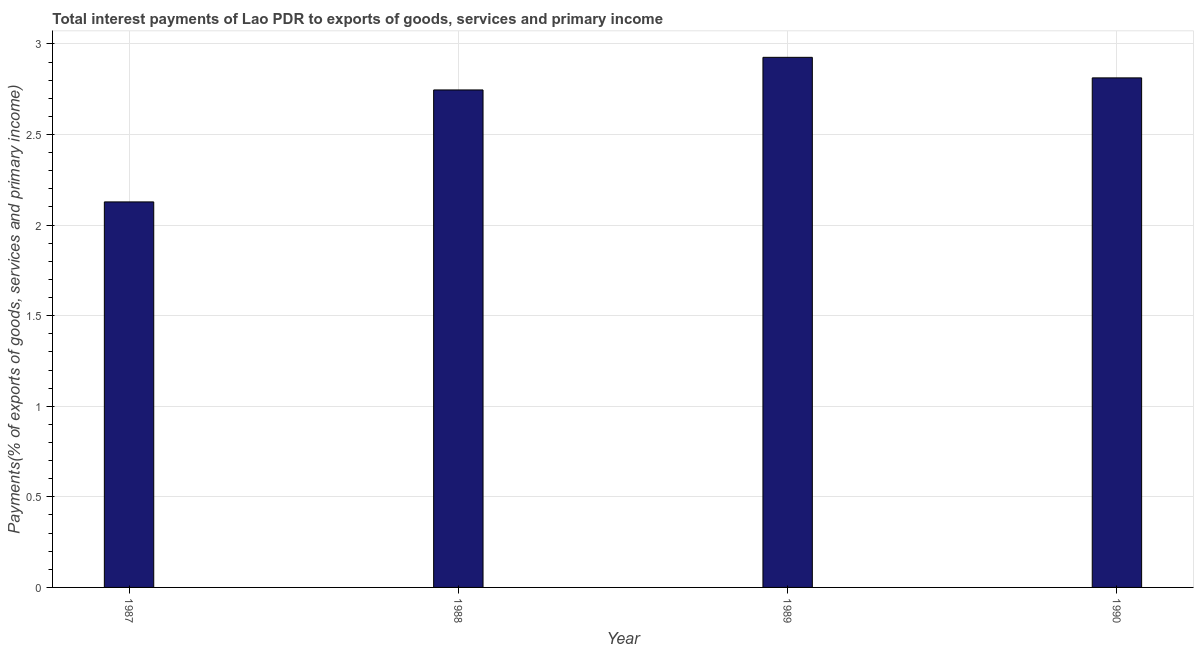Does the graph contain any zero values?
Your answer should be compact. No. Does the graph contain grids?
Offer a terse response. Yes. What is the title of the graph?
Offer a very short reply. Total interest payments of Lao PDR to exports of goods, services and primary income. What is the label or title of the X-axis?
Give a very brief answer. Year. What is the label or title of the Y-axis?
Ensure brevity in your answer.  Payments(% of exports of goods, services and primary income). What is the total interest payments on external debt in 1987?
Give a very brief answer. 2.13. Across all years, what is the maximum total interest payments on external debt?
Give a very brief answer. 2.93. Across all years, what is the minimum total interest payments on external debt?
Your response must be concise. 2.13. What is the sum of the total interest payments on external debt?
Your response must be concise. 10.61. What is the difference between the total interest payments on external debt in 1989 and 1990?
Provide a short and direct response. 0.11. What is the average total interest payments on external debt per year?
Provide a short and direct response. 2.65. What is the median total interest payments on external debt?
Ensure brevity in your answer.  2.78. In how many years, is the total interest payments on external debt greater than 1.3 %?
Your response must be concise. 4. What is the ratio of the total interest payments on external debt in 1988 to that in 1990?
Provide a short and direct response. 0.98. Is the difference between the total interest payments on external debt in 1987 and 1989 greater than the difference between any two years?
Provide a short and direct response. Yes. What is the difference between the highest and the second highest total interest payments on external debt?
Offer a very short reply. 0.11. What is the difference between the highest and the lowest total interest payments on external debt?
Provide a short and direct response. 0.8. In how many years, is the total interest payments on external debt greater than the average total interest payments on external debt taken over all years?
Offer a terse response. 3. How many bars are there?
Keep it short and to the point. 4. Are all the bars in the graph horizontal?
Ensure brevity in your answer.  No. How many years are there in the graph?
Make the answer very short. 4. What is the Payments(% of exports of goods, services and primary income) of 1987?
Your response must be concise. 2.13. What is the Payments(% of exports of goods, services and primary income) in 1988?
Give a very brief answer. 2.75. What is the Payments(% of exports of goods, services and primary income) of 1989?
Give a very brief answer. 2.93. What is the Payments(% of exports of goods, services and primary income) in 1990?
Keep it short and to the point. 2.81. What is the difference between the Payments(% of exports of goods, services and primary income) in 1987 and 1988?
Your response must be concise. -0.62. What is the difference between the Payments(% of exports of goods, services and primary income) in 1987 and 1989?
Ensure brevity in your answer.  -0.8. What is the difference between the Payments(% of exports of goods, services and primary income) in 1987 and 1990?
Offer a very short reply. -0.68. What is the difference between the Payments(% of exports of goods, services and primary income) in 1988 and 1989?
Keep it short and to the point. -0.18. What is the difference between the Payments(% of exports of goods, services and primary income) in 1988 and 1990?
Offer a terse response. -0.07. What is the difference between the Payments(% of exports of goods, services and primary income) in 1989 and 1990?
Provide a succinct answer. 0.11. What is the ratio of the Payments(% of exports of goods, services and primary income) in 1987 to that in 1988?
Provide a short and direct response. 0.78. What is the ratio of the Payments(% of exports of goods, services and primary income) in 1987 to that in 1989?
Your answer should be compact. 0.73. What is the ratio of the Payments(% of exports of goods, services and primary income) in 1987 to that in 1990?
Make the answer very short. 0.76. What is the ratio of the Payments(% of exports of goods, services and primary income) in 1988 to that in 1989?
Provide a succinct answer. 0.94. What is the ratio of the Payments(% of exports of goods, services and primary income) in 1988 to that in 1990?
Offer a terse response. 0.98. 